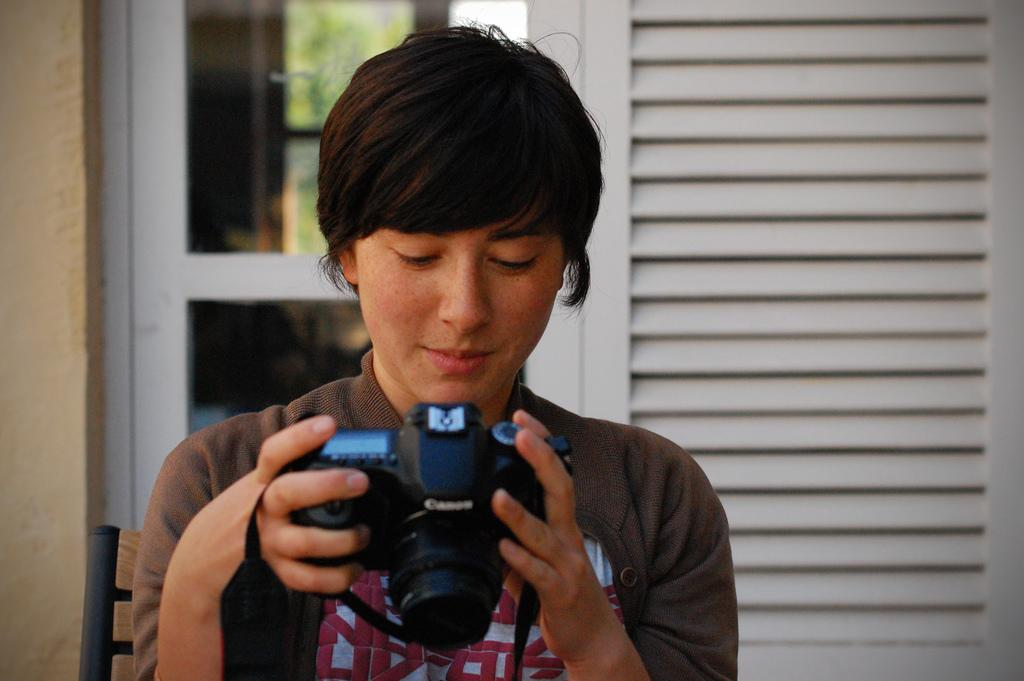What is the main subject of the image? There is a person in the image. What is the person holding in the image? The person is holding a camera. What type of structure is visible in the image? There is a glass window connected to a wall in the image. How many eggs are visible in the image? There are no eggs present in the image. What type of group or flock can be seen in the image? There is no group or flock of animals present in the image. 